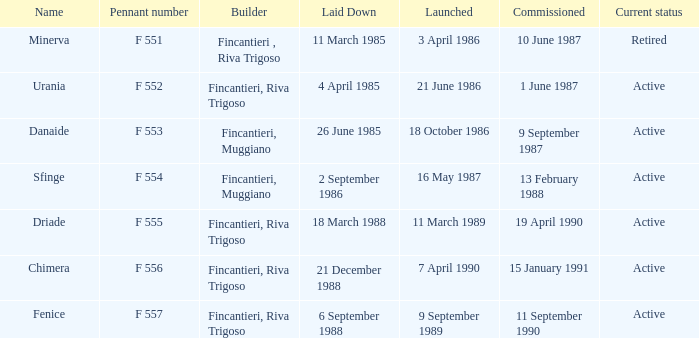Which launch date involved the Driade? 11 March 1989. 